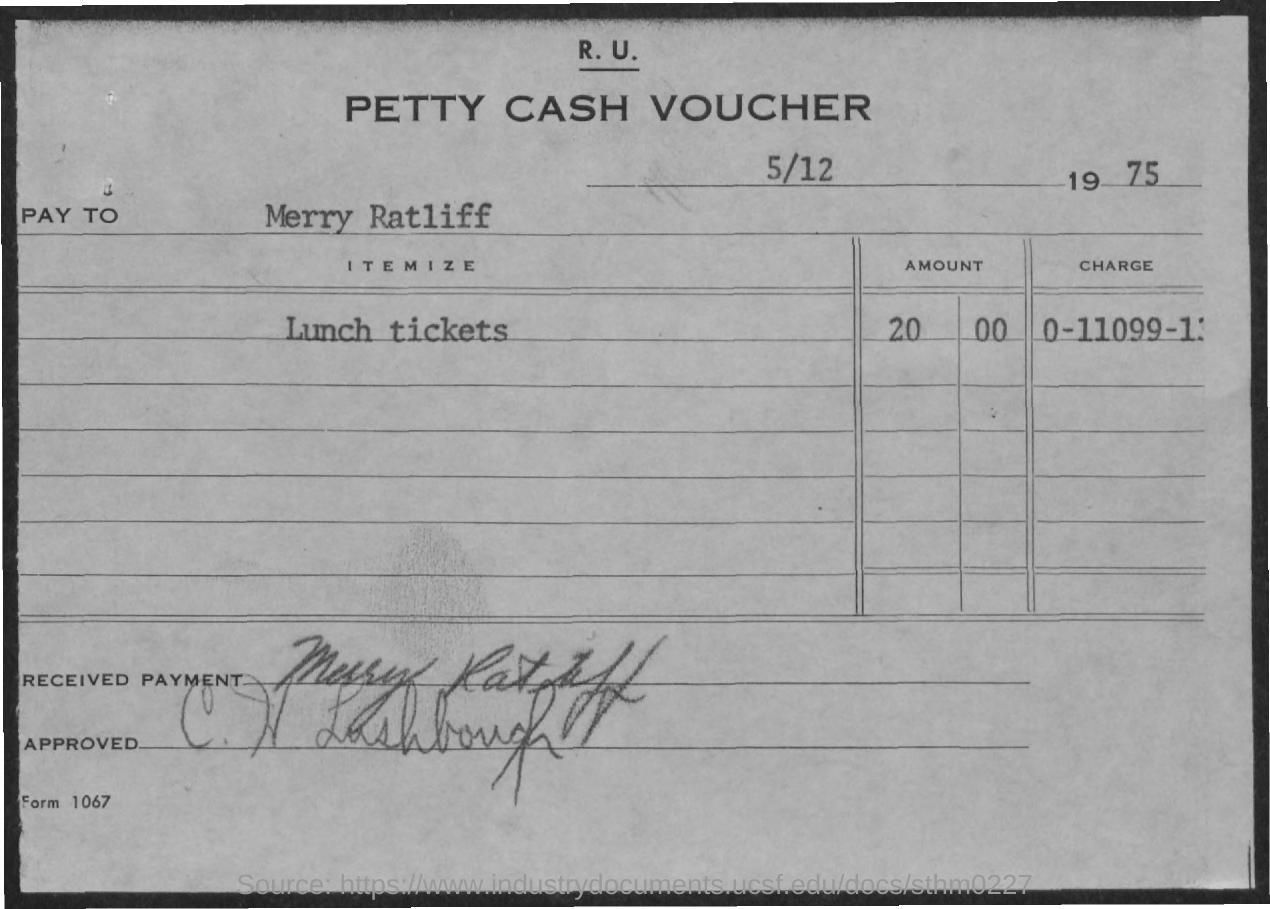Draw attention to some important aspects in this diagram. The payment was received by Merry Ratliff. What is the form number? It is 1067... 